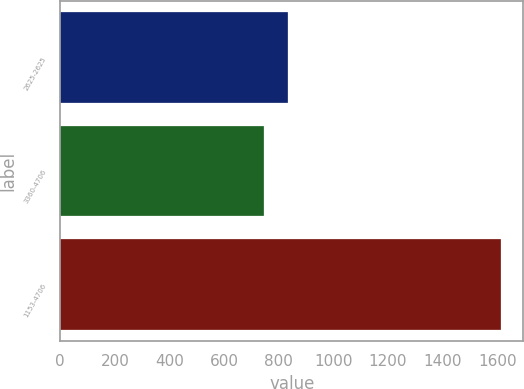<chart> <loc_0><loc_0><loc_500><loc_500><bar_chart><fcel>2625-2625<fcel>3360-4706<fcel>1153-4706<nl><fcel>832.9<fcel>746<fcel>1615<nl></chart> 